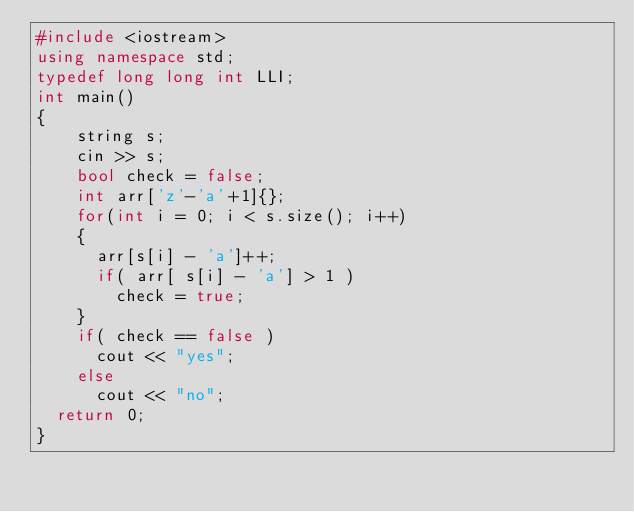<code> <loc_0><loc_0><loc_500><loc_500><_C++_>#include <iostream>
using namespace std;
typedef long long int LLI;
int main()
{
  	string s;
  	cin >> s;
  	bool check = false;
  	int arr['z'-'a'+1]{};
  	for(int i = 0; i < s.size(); i++)
    {
      arr[s[i] - 'a']++;
      if( arr[ s[i] - 'a'] > 1 )
        check = true;
    }
  	if( check == false )
      cout << "yes";
  	else
      cout << "no";
	return 0;
}</code> 